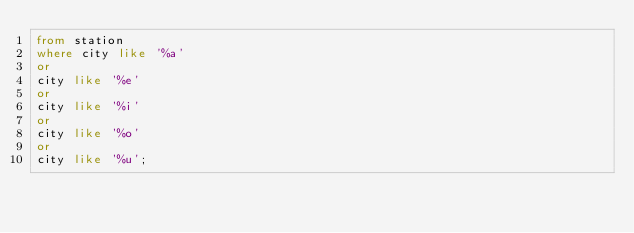Convert code to text. <code><loc_0><loc_0><loc_500><loc_500><_SQL_>from station
where city like '%a'
or
city like '%e'
or
city like '%i'
or
city like '%o'
or
city like '%u';</code> 